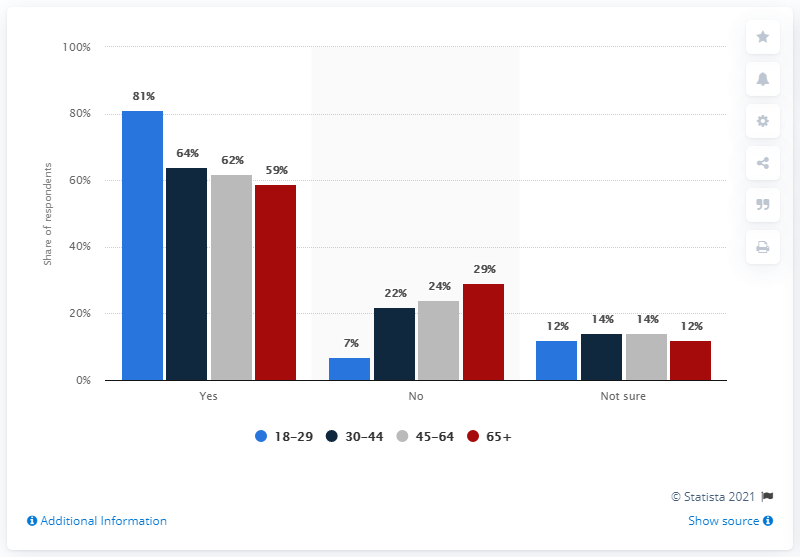How many bars in the chart below 40 %? Upon reviewing the chart, there are five bars that depict percentages below 40%. Specifically, these are 22%, 24%, 29%, 14%, and 12%. Each percentage corresponds to a different age group's response to a survey question. 